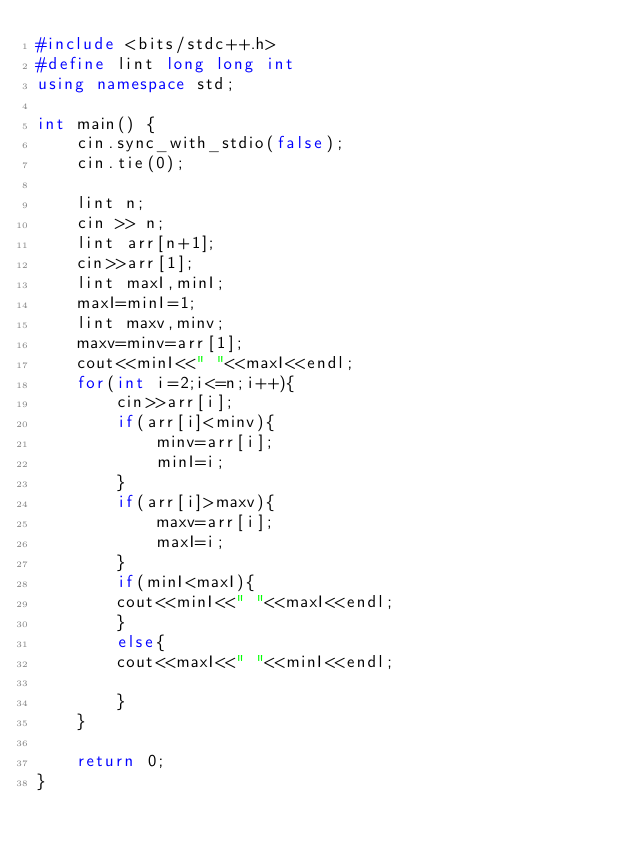<code> <loc_0><loc_0><loc_500><loc_500><_C++_>#include <bits/stdc++.h>
#define lint long long int
using namespace std;

int main() {
    cin.sync_with_stdio(false);
    cin.tie(0);
    
    lint n;
    cin >> n;
    lint arr[n+1];
    cin>>arr[1];
    lint maxI,minI;
    maxI=minI=1;
    lint maxv,minv;
    maxv=minv=arr[1];
    cout<<minI<<" "<<maxI<<endl;
    for(int i=2;i<=n;i++){
        cin>>arr[i];
        if(arr[i]<minv){
            minv=arr[i];
            minI=i;
        }
        if(arr[i]>maxv){
            maxv=arr[i];
            maxI=i;
        }
        if(minI<maxI){
        cout<<minI<<" "<<maxI<<endl;
        }
        else{
        cout<<maxI<<" "<<minI<<endl;
            
        }
    }
    
    return 0;
}
</code> 